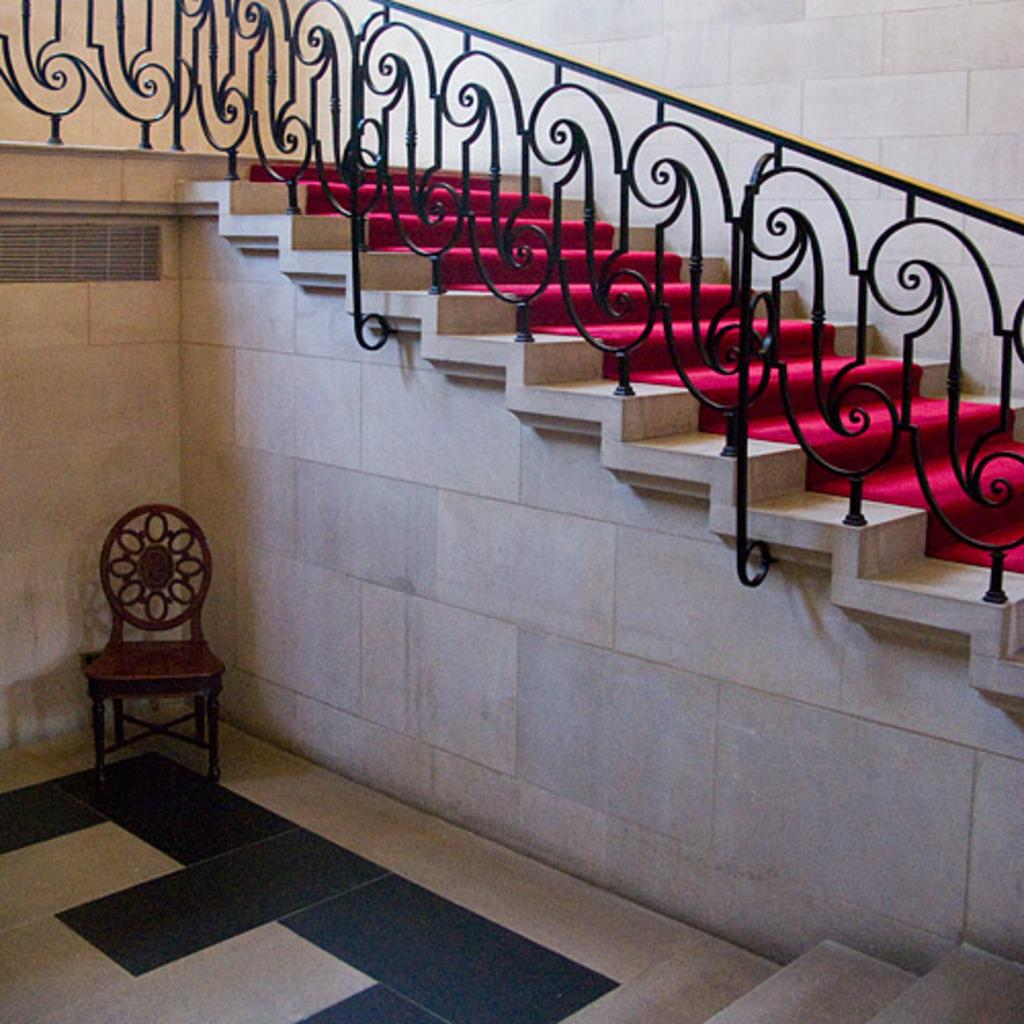What type of furniture is present in the image? There is a chair in the image. What architectural feature can be seen in the background? There is a wall in the image. What surface is the chair and wall placed on? There is a floor in the image. What is a feature that allows for movement between different levels? There are stairs in the image. What safety feature is present near the stairs? There is a railing in the image. Can you see a basket of fire on the chair in the image? There is no basket of fire present in the image. Are the people in the image sharing a kiss? There are no people visible in the image, so it is impossible to determine if they are sharing a kiss. 